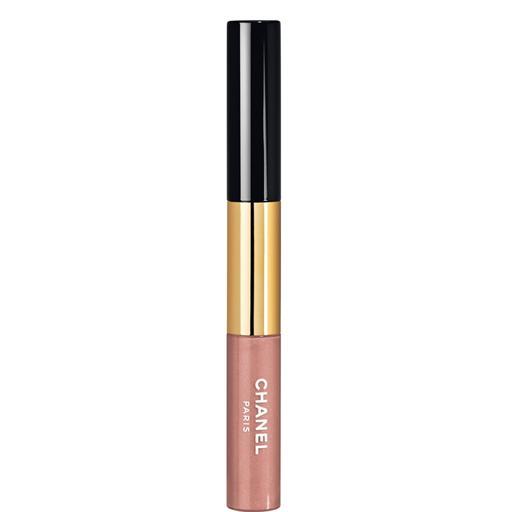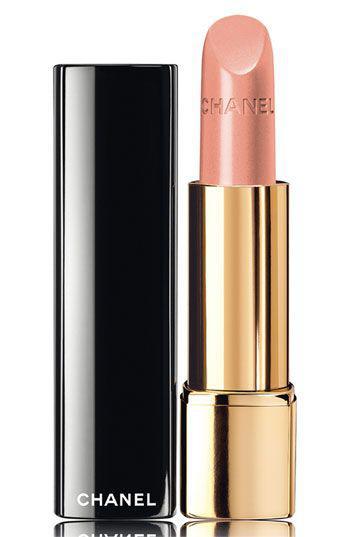The first image is the image on the left, the second image is the image on the right. Evaluate the accuracy of this statement regarding the images: "An image features one orange lipstick standing next to its upright lid.". Is it true? Answer yes or no. No. The first image is the image on the left, the second image is the image on the right. For the images shown, is this caption "One lipstick is extended to show its color with its cap sitting beside it, while a second lipstick is closed, but with a visible color." true? Answer yes or no. Yes. 